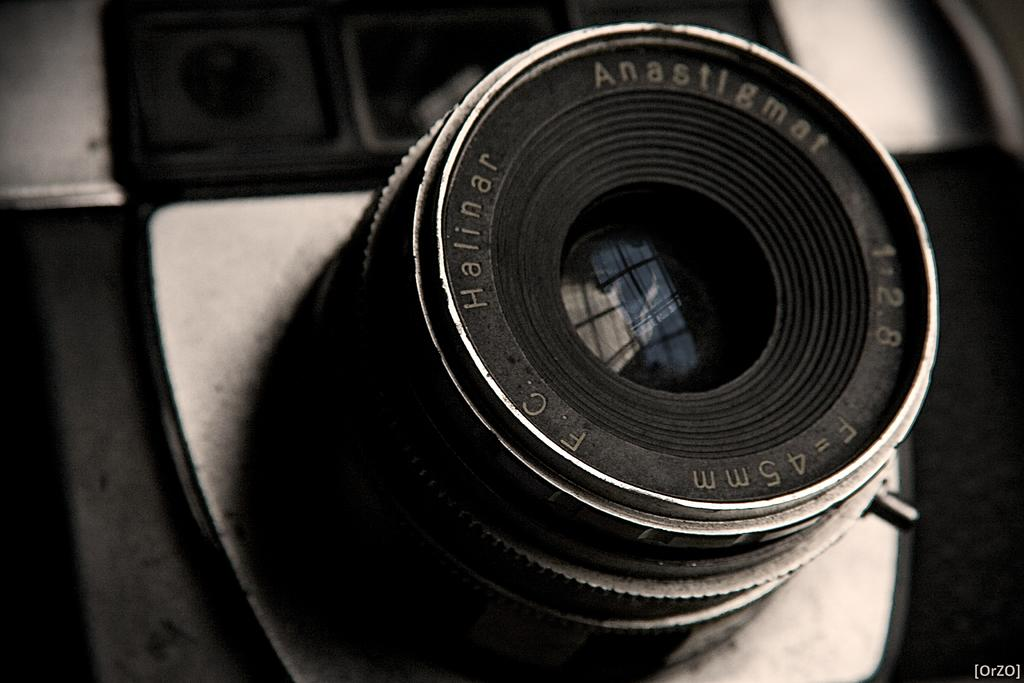What is the main subject of the image? The main subject of the image is a camera lens. What color is the camera lens? The camera lens is black in color. Is there a veil covering the camera lens in the image? No, there is no veil present in the image. Can you see anyone saying good-bye in the image? There is no indication of anyone saying good-bye in the image, as it only features a camera lens. 